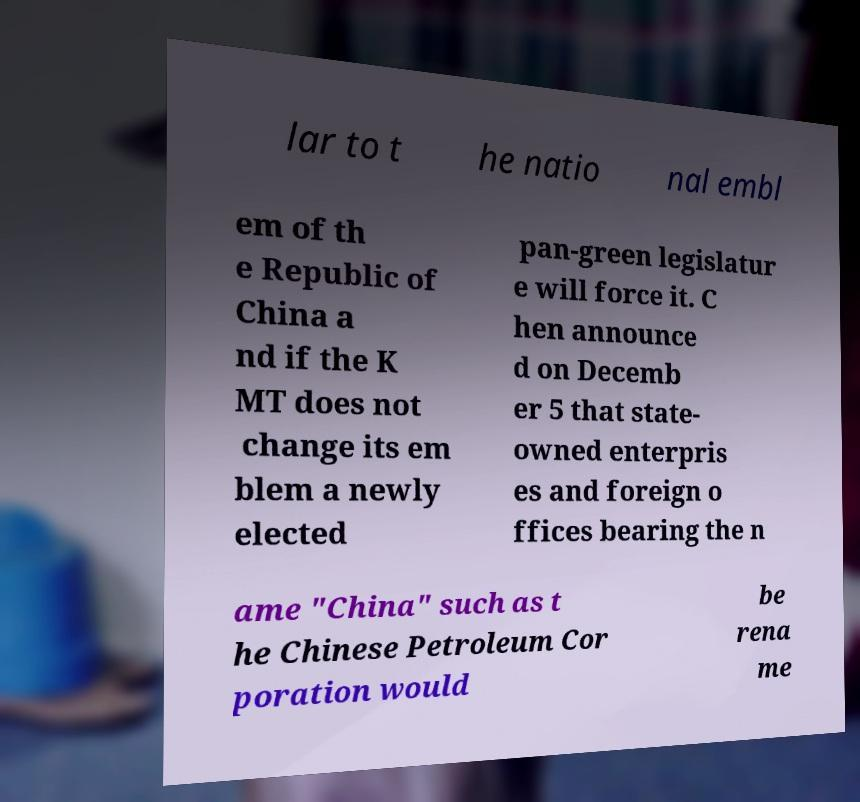Can you read and provide the text displayed in the image?This photo seems to have some interesting text. Can you extract and type it out for me? lar to t he natio nal embl em of th e Republic of China a nd if the K MT does not change its em blem a newly elected pan-green legislatur e will force it. C hen announce d on Decemb er 5 that state- owned enterpris es and foreign o ffices bearing the n ame "China" such as t he Chinese Petroleum Cor poration would be rena me 